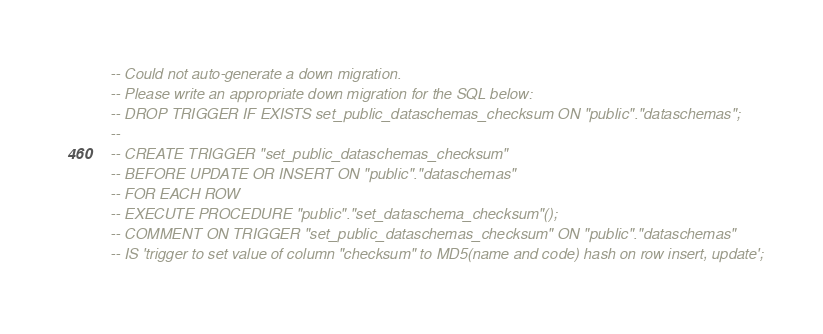<code> <loc_0><loc_0><loc_500><loc_500><_SQL_>-- Could not auto-generate a down migration.
-- Please write an appropriate down migration for the SQL below:
-- DROP TRIGGER IF EXISTS set_public_dataschemas_checksum ON "public"."dataschemas";
--
-- CREATE TRIGGER "set_public_dataschemas_checksum"
-- BEFORE UPDATE OR INSERT ON "public"."dataschemas"
-- FOR EACH ROW
-- EXECUTE PROCEDURE "public"."set_dataschema_checksum"();
-- COMMENT ON TRIGGER "set_public_dataschemas_checksum" ON "public"."dataschemas"
-- IS 'trigger to set value of column "checksum" to MD5(name and code) hash on row insert, update';
</code> 